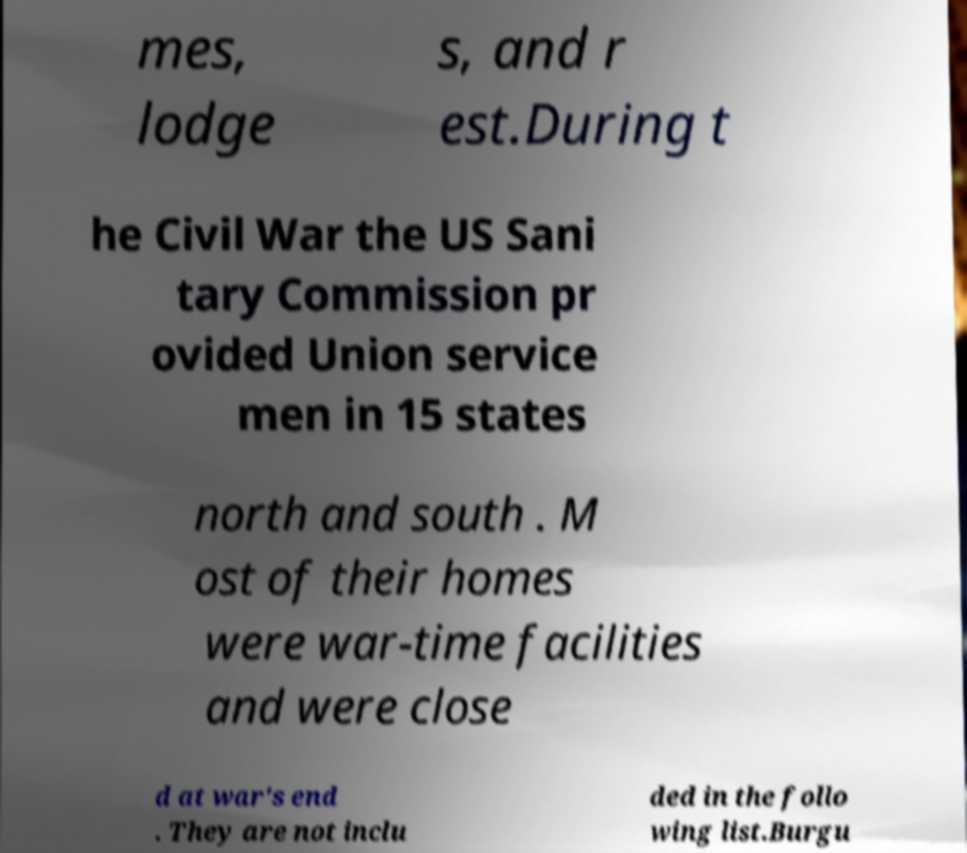Please read and relay the text visible in this image. What does it say? mes, lodge s, and r est.During t he Civil War the US Sani tary Commission pr ovided Union service men in 15 states north and south . M ost of their homes were war-time facilities and were close d at war's end . They are not inclu ded in the follo wing list.Burgu 